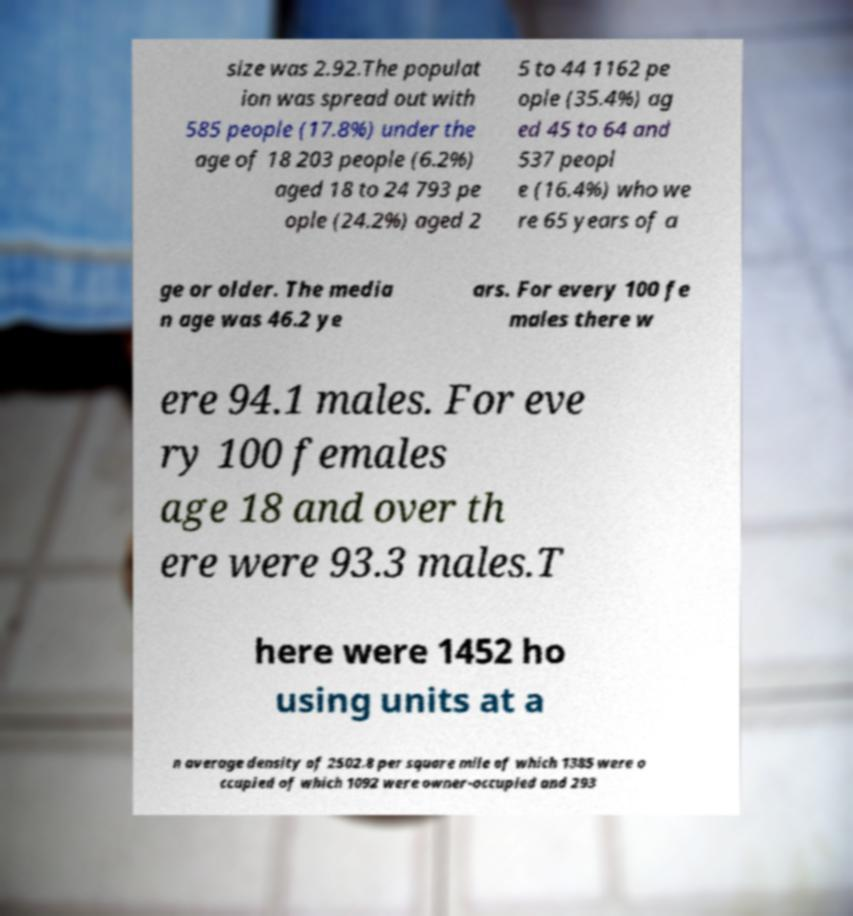Could you extract and type out the text from this image? size was 2.92.The populat ion was spread out with 585 people (17.8%) under the age of 18 203 people (6.2%) aged 18 to 24 793 pe ople (24.2%) aged 2 5 to 44 1162 pe ople (35.4%) ag ed 45 to 64 and 537 peopl e (16.4%) who we re 65 years of a ge or older. The media n age was 46.2 ye ars. For every 100 fe males there w ere 94.1 males. For eve ry 100 females age 18 and over th ere were 93.3 males.T here were 1452 ho using units at a n average density of 2502.8 per square mile of which 1385 were o ccupied of which 1092 were owner-occupied and 293 